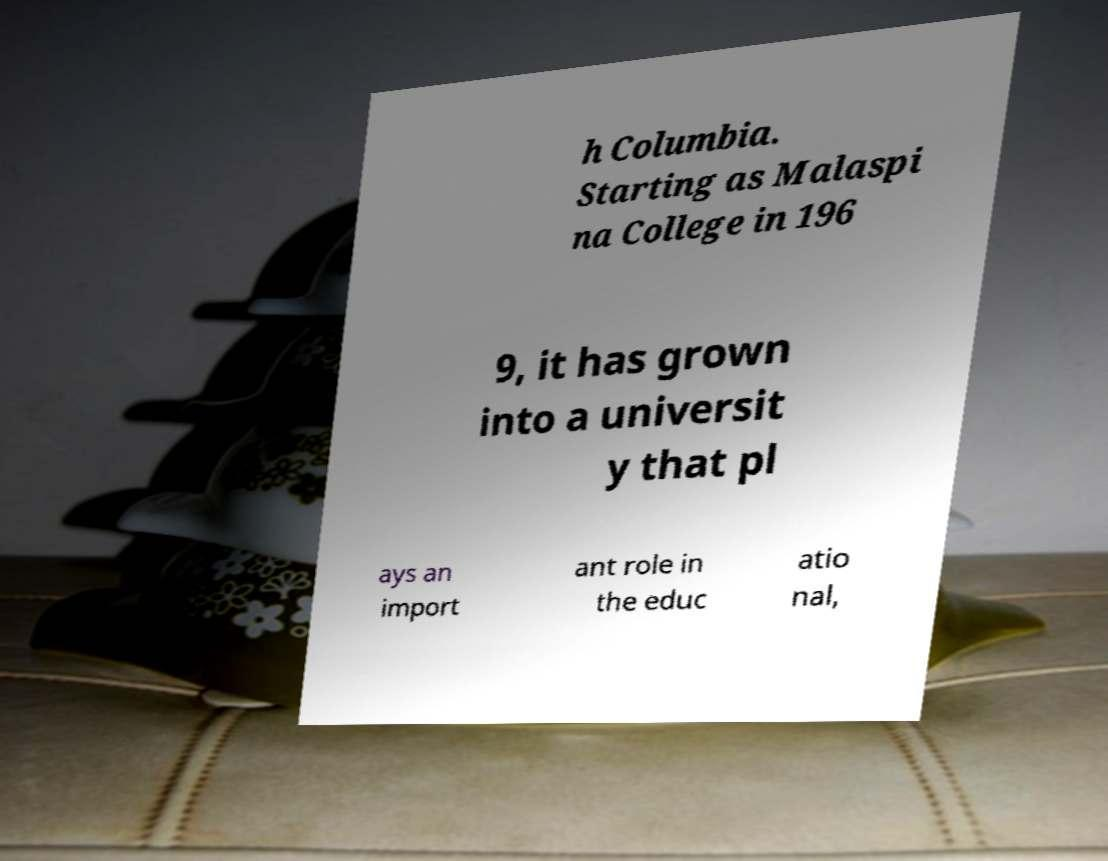I need the written content from this picture converted into text. Can you do that? h Columbia. Starting as Malaspi na College in 196 9, it has grown into a universit y that pl ays an import ant role in the educ atio nal, 